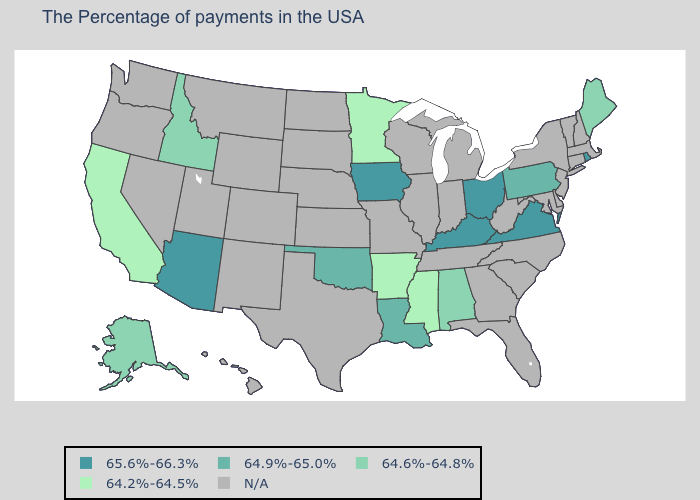What is the value of Illinois?
Short answer required. N/A. Name the states that have a value in the range N/A?
Give a very brief answer. Massachusetts, New Hampshire, Vermont, Connecticut, New York, New Jersey, Delaware, Maryland, North Carolina, South Carolina, West Virginia, Florida, Georgia, Michigan, Indiana, Tennessee, Wisconsin, Illinois, Missouri, Kansas, Nebraska, Texas, South Dakota, North Dakota, Wyoming, Colorado, New Mexico, Utah, Montana, Nevada, Washington, Oregon, Hawaii. What is the value of Nebraska?
Give a very brief answer. N/A. Which states have the highest value in the USA?
Quick response, please. Rhode Island, Virginia, Ohio, Kentucky, Iowa, Arizona. Name the states that have a value in the range 64.6%-64.8%?
Answer briefly. Maine, Alabama, Idaho, Alaska. Is the legend a continuous bar?
Short answer required. No. Which states have the highest value in the USA?
Be succinct. Rhode Island, Virginia, Ohio, Kentucky, Iowa, Arizona. Is the legend a continuous bar?
Keep it brief. No. What is the highest value in the USA?
Concise answer only. 65.6%-66.3%. What is the value of New Mexico?
Write a very short answer. N/A. How many symbols are there in the legend?
Be succinct. 5. Name the states that have a value in the range 64.9%-65.0%?
Keep it brief. Pennsylvania, Louisiana, Oklahoma. 